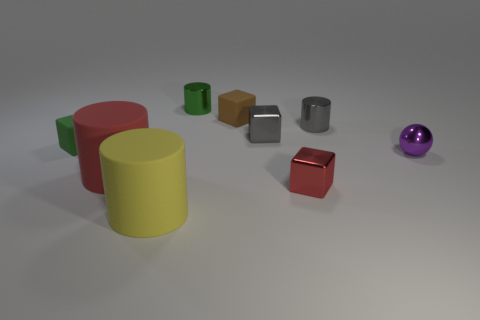Subtract 2 blocks. How many blocks are left? 2 Subtract all green cylinders. How many cylinders are left? 3 Subtract all brown cubes. How many cubes are left? 3 Add 1 green objects. How many objects exist? 10 Subtract all cubes. How many objects are left? 5 Subtract all red cylinders. Subtract all purple balls. How many cylinders are left? 3 Add 6 tiny metal cylinders. How many tiny metal cylinders are left? 8 Add 6 small purple rubber cylinders. How many small purple rubber cylinders exist? 6 Subtract 0 gray balls. How many objects are left? 9 Subtract all small gray blocks. Subtract all green matte objects. How many objects are left? 7 